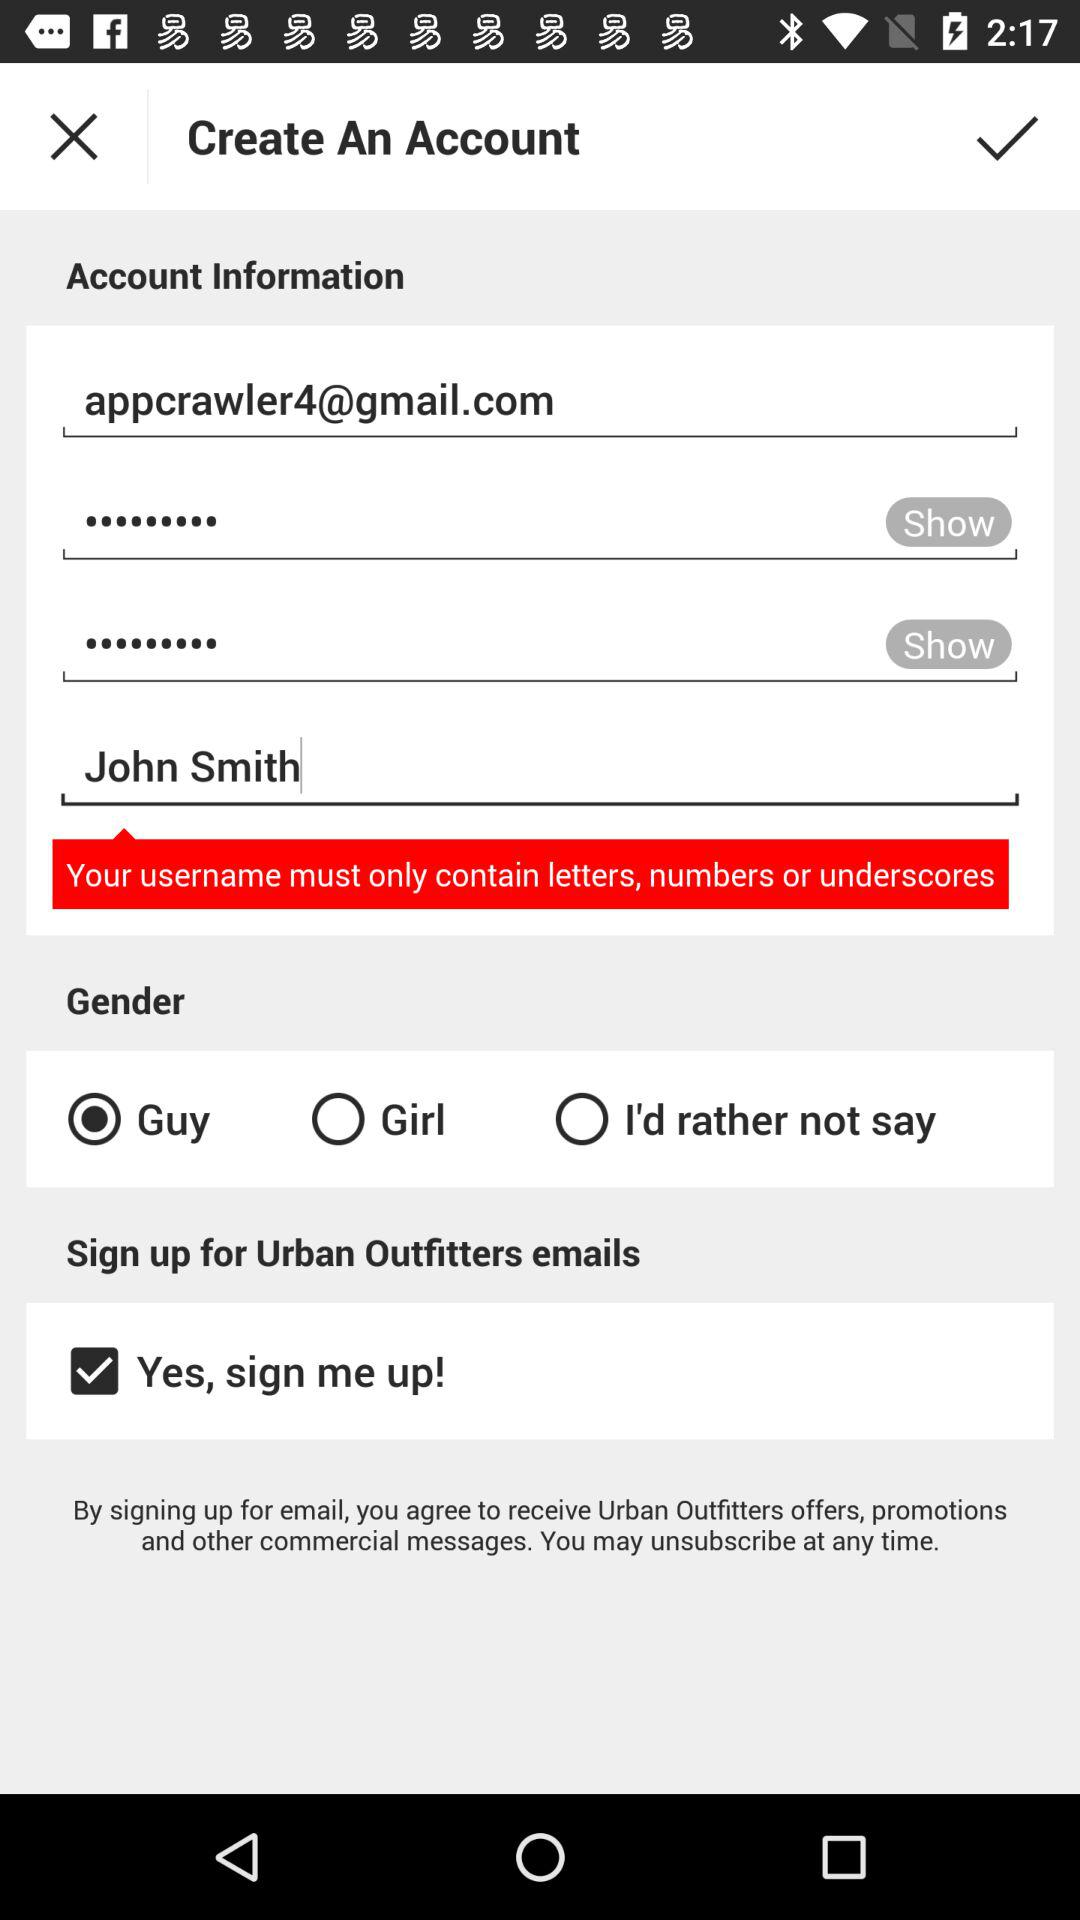What is the email address of the user? The email address is appcrawler4@gmail.com. 